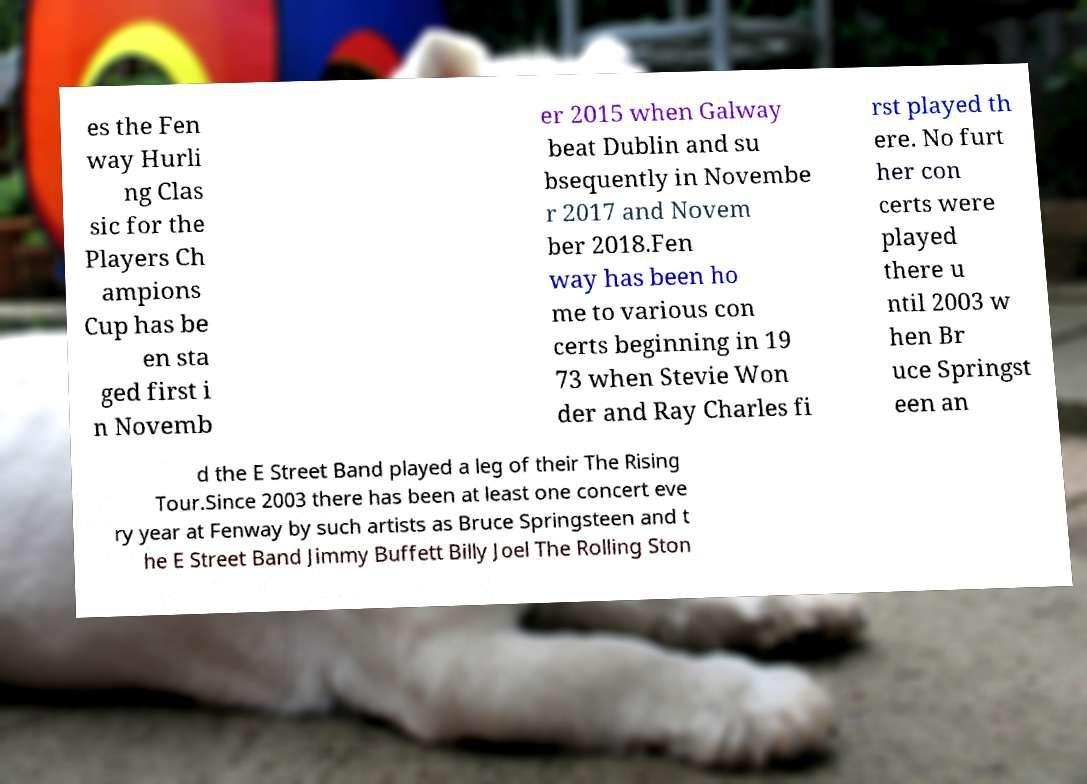Please identify and transcribe the text found in this image. es the Fen way Hurli ng Clas sic for the Players Ch ampions Cup has be en sta ged first i n Novemb er 2015 when Galway beat Dublin and su bsequently in Novembe r 2017 and Novem ber 2018.Fen way has been ho me to various con certs beginning in 19 73 when Stevie Won der and Ray Charles fi rst played th ere. No furt her con certs were played there u ntil 2003 w hen Br uce Springst een an d the E Street Band played a leg of their The Rising Tour.Since 2003 there has been at least one concert eve ry year at Fenway by such artists as Bruce Springsteen and t he E Street Band Jimmy Buffett Billy Joel The Rolling Ston 